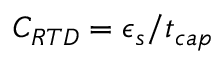Convert formula to latex. <formula><loc_0><loc_0><loc_500><loc_500>C _ { R T D } = \epsilon _ { s } / t _ { c a p }</formula> 